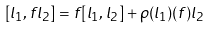<formula> <loc_0><loc_0><loc_500><loc_500>[ l _ { 1 } , f l _ { 2 } ] = f [ l _ { 1 } , l _ { 2 } ] + \rho ( l _ { 1 } ) ( f ) l _ { 2 }</formula> 